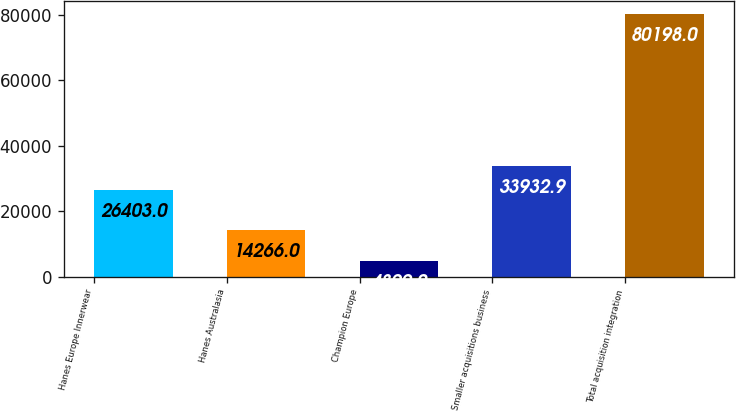Convert chart. <chart><loc_0><loc_0><loc_500><loc_500><bar_chart><fcel>Hanes Europe Innerwear<fcel>Hanes Australasia<fcel>Champion Europe<fcel>Smaller acquisitions business<fcel>Total acquisition integration<nl><fcel>26403<fcel>14266<fcel>4899<fcel>33932.9<fcel>80198<nl></chart> 